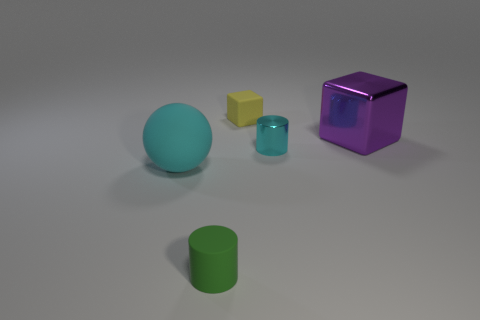There is a purple object; does it have the same shape as the matte thing that is behind the tiny cyan cylinder?
Provide a short and direct response. Yes. What number of other things are the same shape as the purple metal thing?
Your answer should be compact. 1. What number of objects are either tiny cyan metallic cylinders or small red matte cubes?
Your answer should be compact. 1. Do the tiny cube and the large sphere have the same color?
Make the answer very short. No. Is there any other thing that has the same size as the ball?
Ensure brevity in your answer.  Yes. What is the shape of the tiny matte thing in front of the tiny rubber thing that is behind the big metal object?
Give a very brief answer. Cylinder. Are there fewer rubber cubes than large cylinders?
Offer a very short reply. No. There is a object that is to the left of the cyan metallic cylinder and behind the cyan ball; what size is it?
Make the answer very short. Small. Do the cyan rubber object and the green matte thing have the same size?
Provide a succinct answer. No. Do the tiny cylinder that is on the right side of the tiny yellow matte thing and the big metal object have the same color?
Provide a succinct answer. No. 